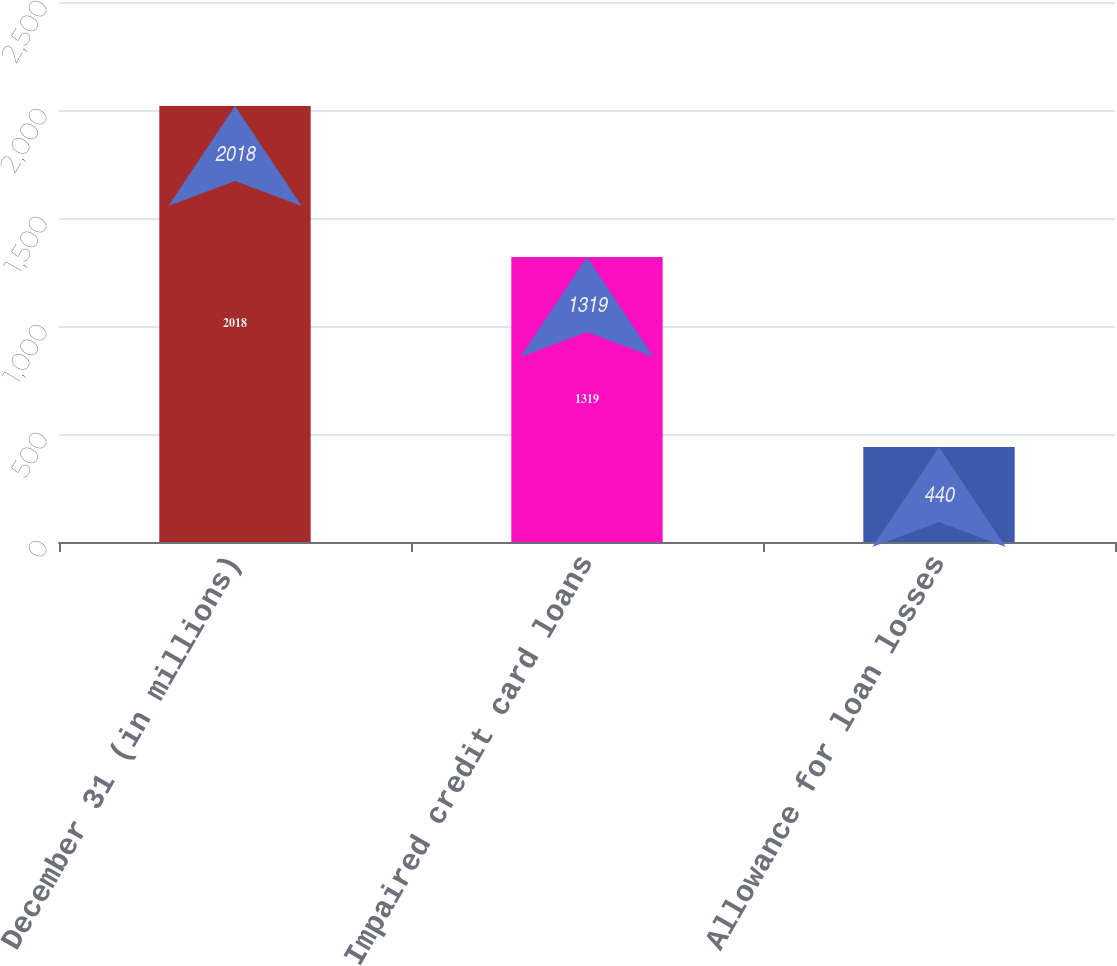<chart> <loc_0><loc_0><loc_500><loc_500><bar_chart><fcel>December 31 (in millions)<fcel>Impaired credit card loans<fcel>Allowance for loan losses<nl><fcel>2018<fcel>1319<fcel>440<nl></chart> 